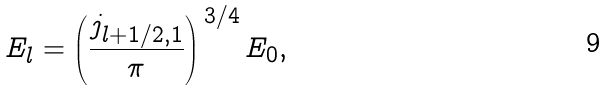<formula> <loc_0><loc_0><loc_500><loc_500>E _ { l } = \left ( \frac { j _ { l + 1 / 2 , 1 } } { \pi } \right ) ^ { \, 3 / 4 } E _ { 0 } ,</formula> 